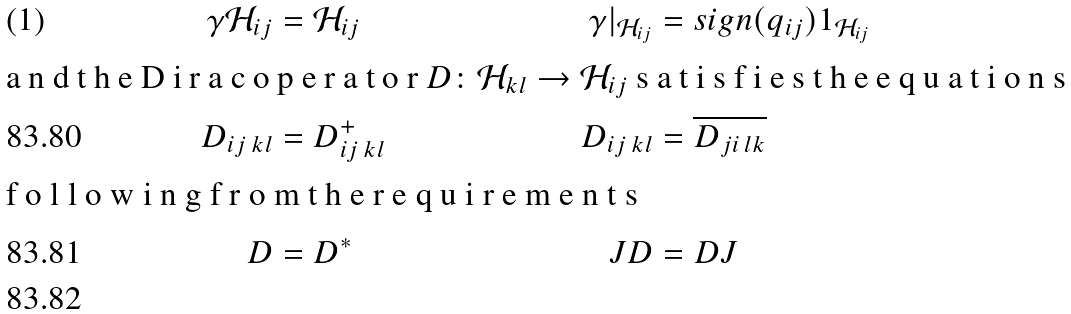Convert formula to latex. <formula><loc_0><loc_0><loc_500><loc_500>\gamma \mathcal { H } _ { i j } & = \mathcal { H } _ { i j } & \gamma { | } _ { \mathcal { H } _ { i j } } & = s i g n ( { q } _ { i j } ) 1 _ { \mathcal { H } _ { i j } } \intertext { a n d t h e D i r a c o p e r a t o r $ D \colon \mathcal { H } _ { k l } \rightarrow \mathcal { H } _ { i j } $ s a t i s f i e s t h e e q u a t i o n s } D _ { i j \, k l } & = D _ { i j \, k l } ^ { + } & D _ { i j \, k l } & = \overline { D _ { j i \, l k } } \\ \intertext { f o l l o w i n g f r o m t h e r e q u i r e m e n t s } D & = { D } ^ { \ast } & J D & = D J \\</formula> 